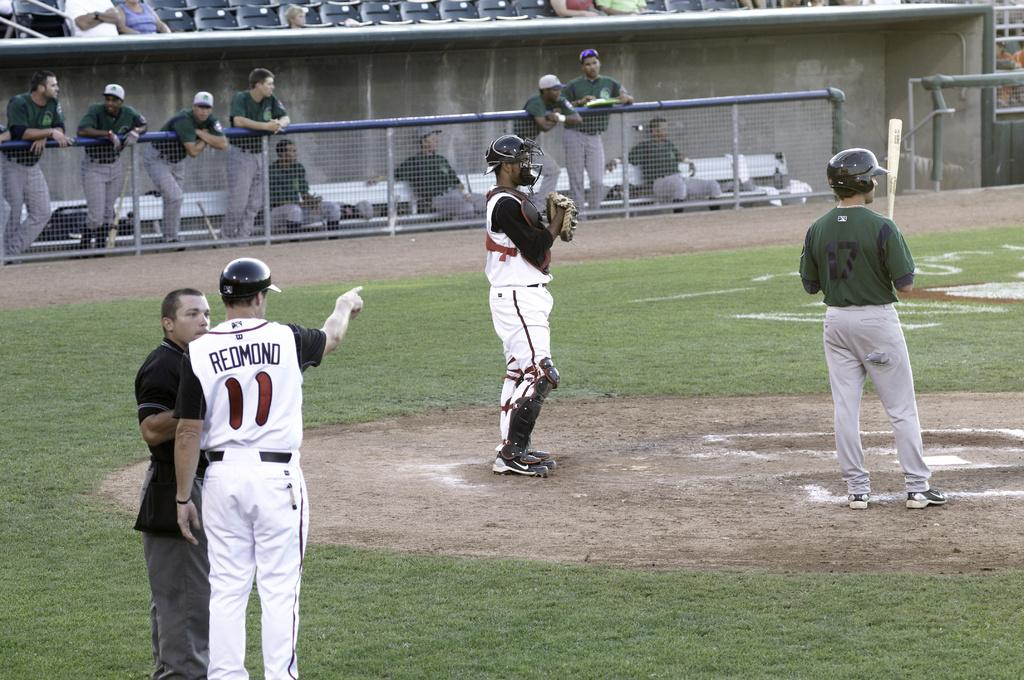Provide a one-sentence caption for the provided image. A baseball player wearing a jersey with the name Redmond on the back points at the home plate. 